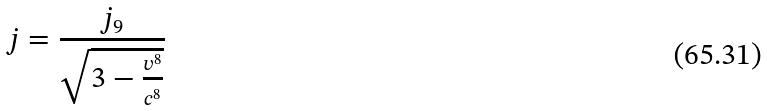Convert formula to latex. <formula><loc_0><loc_0><loc_500><loc_500>j = \frac { j _ { 9 } } { \sqrt { 3 - \frac { v ^ { 8 } } { c ^ { 8 } } } }</formula> 